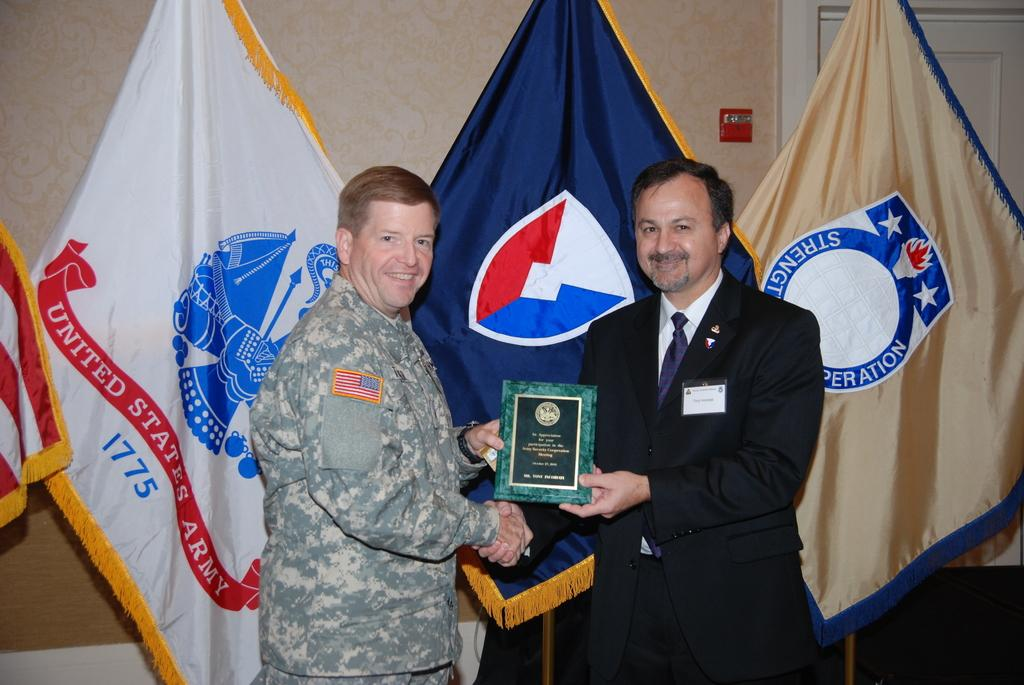<image>
Render a clear and concise summary of the photo. one of the flags in the back says United States Army 1775 